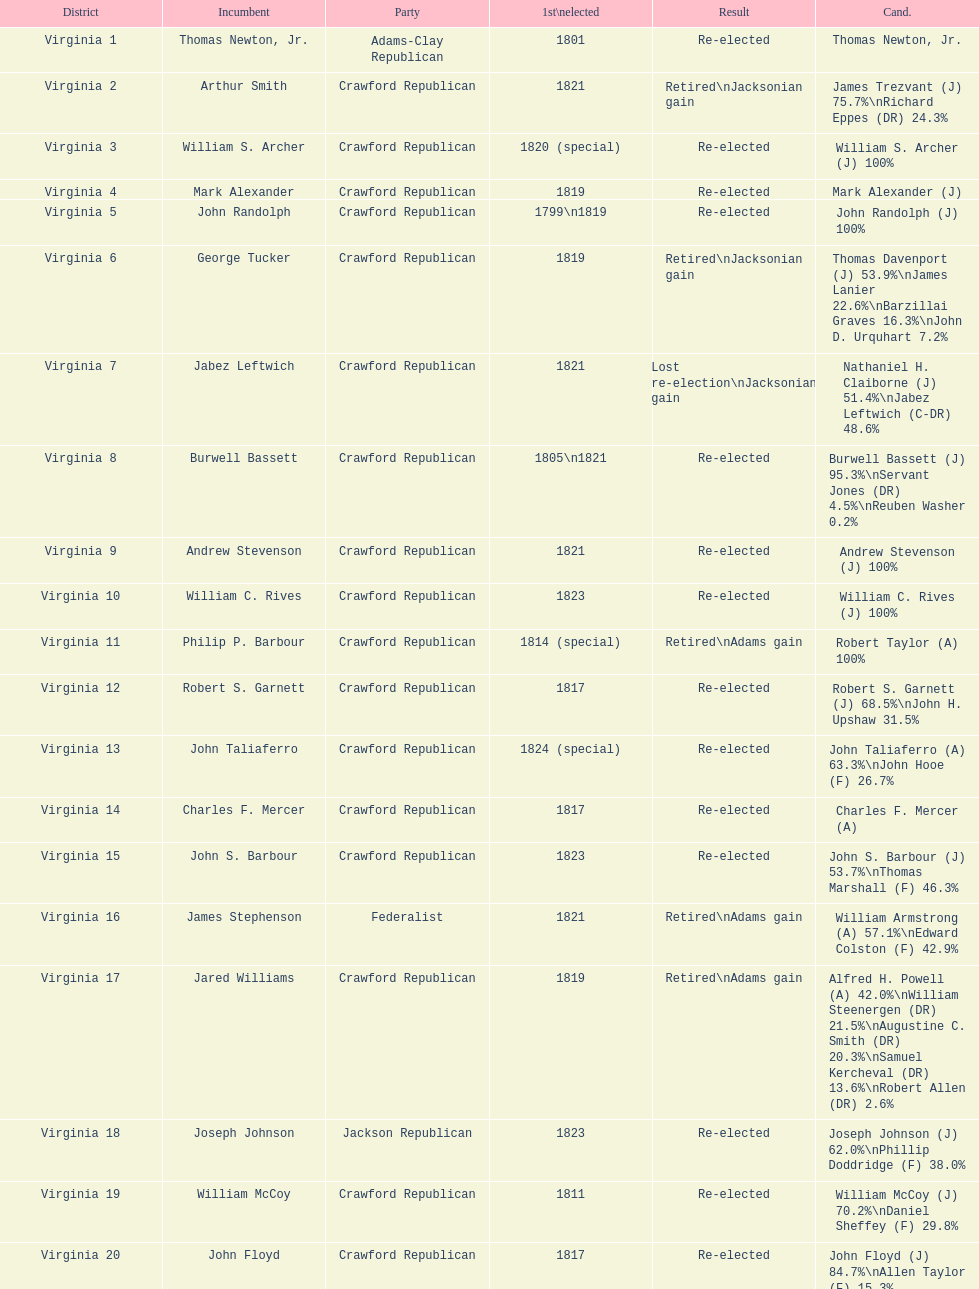Name the only candidate that was first elected in 1811. William McCoy. 